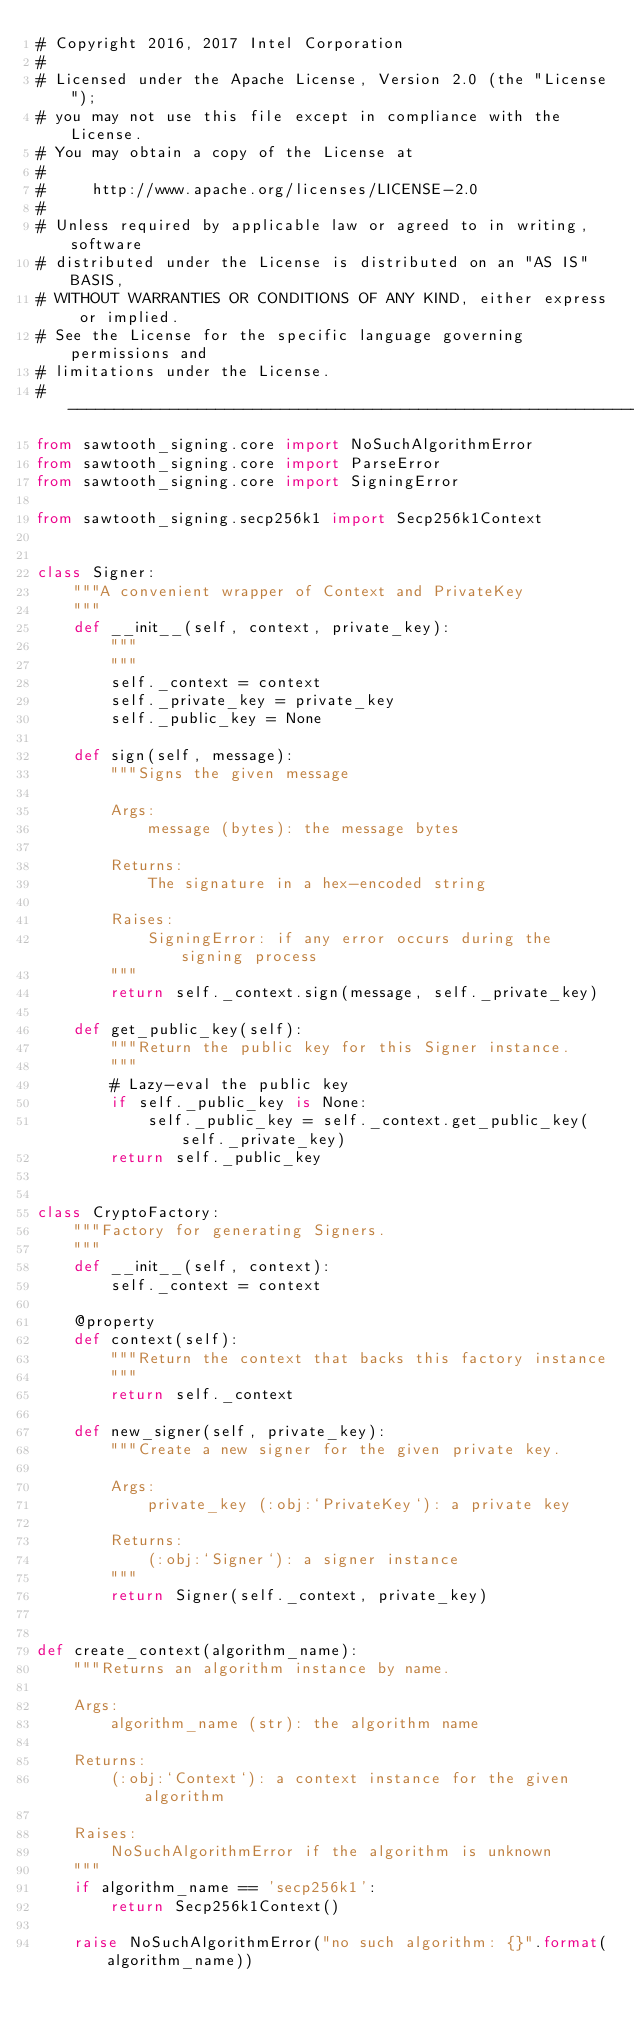Convert code to text. <code><loc_0><loc_0><loc_500><loc_500><_Python_># Copyright 2016, 2017 Intel Corporation
#
# Licensed under the Apache License, Version 2.0 (the "License");
# you may not use this file except in compliance with the License.
# You may obtain a copy of the License at
#
#     http://www.apache.org/licenses/LICENSE-2.0
#
# Unless required by applicable law or agreed to in writing, software
# distributed under the License is distributed on an "AS IS" BASIS,
# WITHOUT WARRANTIES OR CONDITIONS OF ANY KIND, either express or implied.
# See the License for the specific language governing permissions and
# limitations under the License.
# ------------------------------------------------------------------------------
from sawtooth_signing.core import NoSuchAlgorithmError
from sawtooth_signing.core import ParseError
from sawtooth_signing.core import SigningError

from sawtooth_signing.secp256k1 import Secp256k1Context


class Signer:
    """A convenient wrapper of Context and PrivateKey
    """
    def __init__(self, context, private_key):
        """
        """
        self._context = context
        self._private_key = private_key
        self._public_key = None

    def sign(self, message):
        """Signs the given message

        Args:
            message (bytes): the message bytes

        Returns:
            The signature in a hex-encoded string

        Raises:
            SigningError: if any error occurs during the signing process
        """
        return self._context.sign(message, self._private_key)

    def get_public_key(self):
        """Return the public key for this Signer instance.
        """
        # Lazy-eval the public key
        if self._public_key is None:
            self._public_key = self._context.get_public_key(self._private_key)
        return self._public_key


class CryptoFactory:
    """Factory for generating Signers.
    """
    def __init__(self, context):
        self._context = context

    @property
    def context(self):
        """Return the context that backs this factory instance
        """
        return self._context

    def new_signer(self, private_key):
        """Create a new signer for the given private key.

        Args:
            private_key (:obj:`PrivateKey`): a private key

        Returns:
            (:obj:`Signer`): a signer instance
        """
        return Signer(self._context, private_key)


def create_context(algorithm_name):
    """Returns an algorithm instance by name.

    Args:
        algorithm_name (str): the algorithm name

    Returns:
        (:obj:`Context`): a context instance for the given algorithm

    Raises:
        NoSuchAlgorithmError if the algorithm is unknown
    """
    if algorithm_name == 'secp256k1':
        return Secp256k1Context()

    raise NoSuchAlgorithmError("no such algorithm: {}".format(algorithm_name))
</code> 